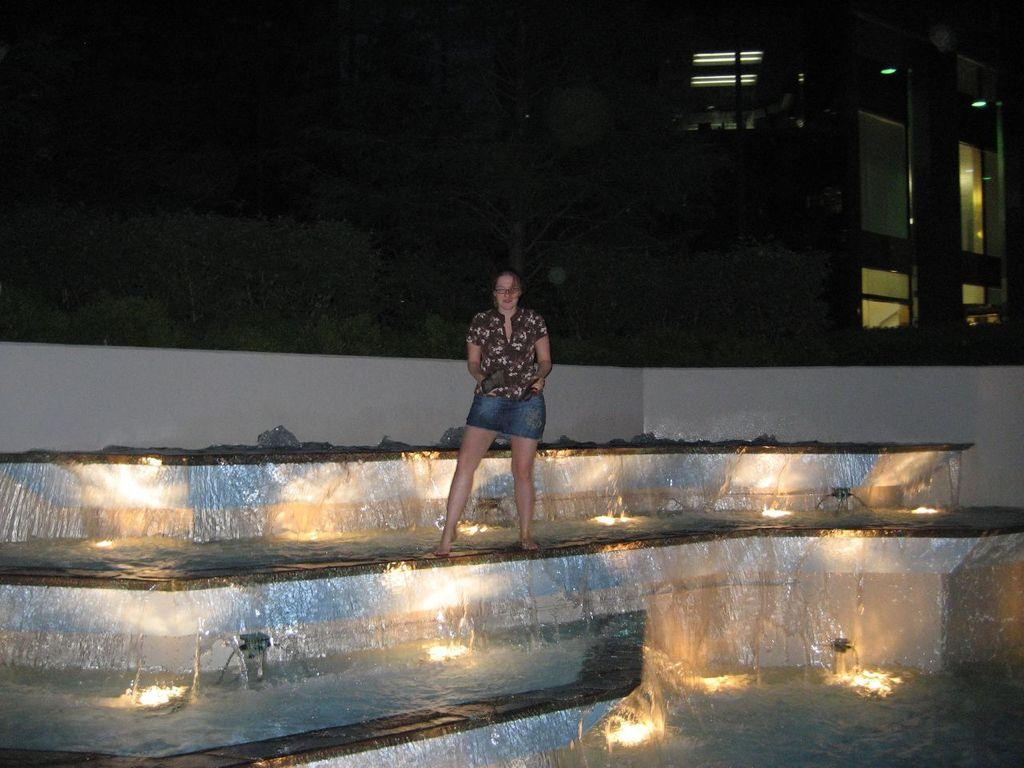What is the person in the image doing? The person is standing on the water in the image. What is the person wearing? The person is wearing a brown shirt and blue shorts. What can be seen in the image besides the person? There are stairs, lights, and buildings visible in the image. What type of frame surrounds the person in the image? There is no frame surrounding the person in the image; it is a photograph or digital image without a physical frame. 